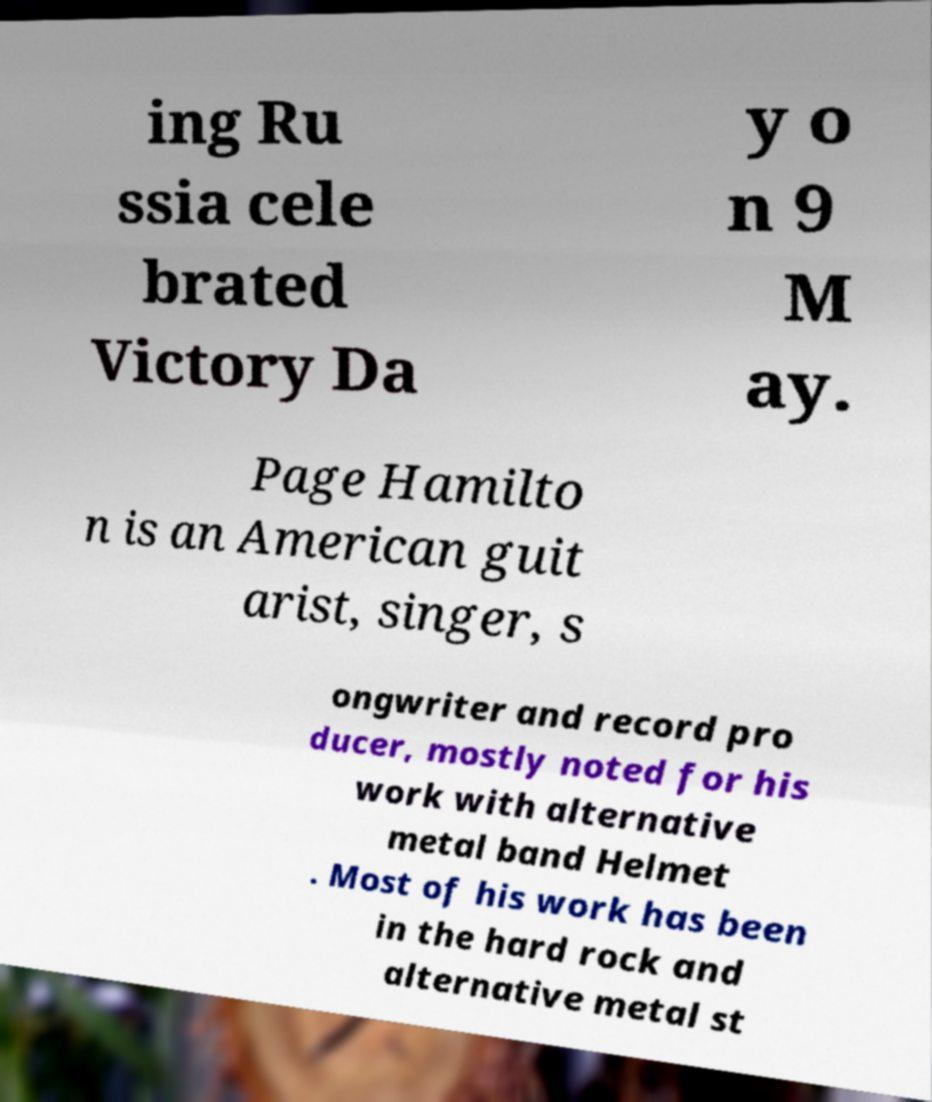Can you accurately transcribe the text from the provided image for me? ing Ru ssia cele brated Victory Da y o n 9 M ay. Page Hamilto n is an American guit arist, singer, s ongwriter and record pro ducer, mostly noted for his work with alternative metal band Helmet . Most of his work has been in the hard rock and alternative metal st 